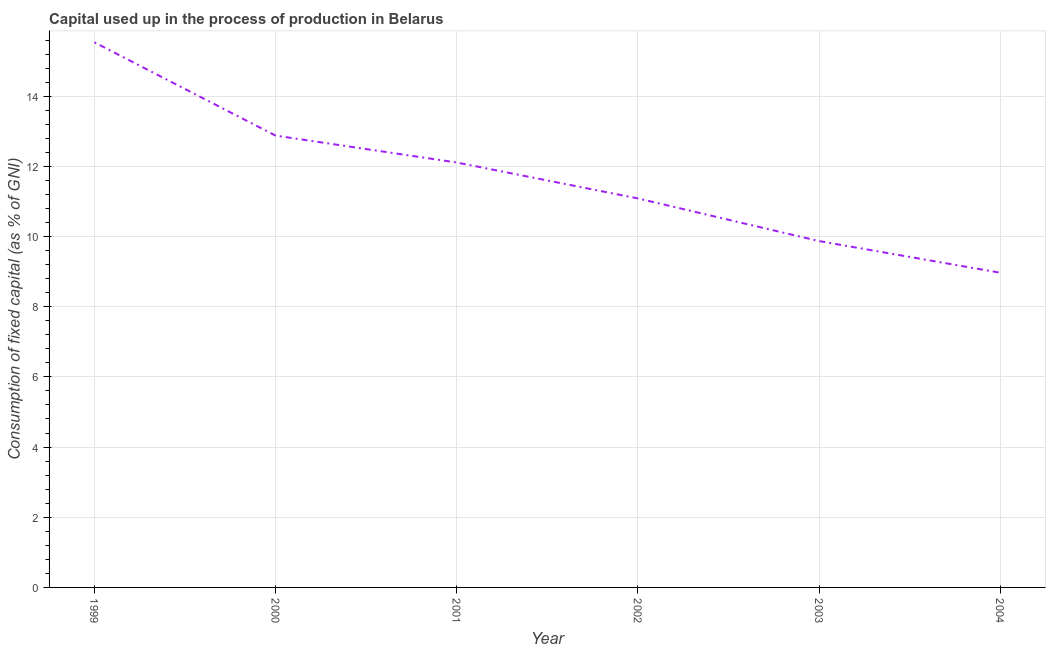What is the consumption of fixed capital in 2004?
Offer a terse response. 8.97. Across all years, what is the maximum consumption of fixed capital?
Offer a very short reply. 15.53. Across all years, what is the minimum consumption of fixed capital?
Your answer should be compact. 8.97. In which year was the consumption of fixed capital minimum?
Keep it short and to the point. 2004. What is the sum of the consumption of fixed capital?
Ensure brevity in your answer.  70.44. What is the difference between the consumption of fixed capital in 1999 and 2003?
Provide a short and direct response. 5.66. What is the average consumption of fixed capital per year?
Make the answer very short. 11.74. What is the median consumption of fixed capital?
Offer a very short reply. 11.6. In how many years, is the consumption of fixed capital greater than 8.4 %?
Provide a short and direct response. 6. Do a majority of the years between 2003 and 2002 (inclusive) have consumption of fixed capital greater than 13.2 %?
Keep it short and to the point. No. What is the ratio of the consumption of fixed capital in 1999 to that in 2004?
Your answer should be compact. 1.73. Is the difference between the consumption of fixed capital in 2000 and 2003 greater than the difference between any two years?
Make the answer very short. No. What is the difference between the highest and the second highest consumption of fixed capital?
Keep it short and to the point. 2.66. Is the sum of the consumption of fixed capital in 2000 and 2003 greater than the maximum consumption of fixed capital across all years?
Give a very brief answer. Yes. What is the difference between the highest and the lowest consumption of fixed capital?
Your answer should be very brief. 6.57. How many lines are there?
Offer a terse response. 1. What is the difference between two consecutive major ticks on the Y-axis?
Your answer should be very brief. 2. Are the values on the major ticks of Y-axis written in scientific E-notation?
Make the answer very short. No. Does the graph contain grids?
Your answer should be very brief. Yes. What is the title of the graph?
Offer a terse response. Capital used up in the process of production in Belarus. What is the label or title of the X-axis?
Ensure brevity in your answer.  Year. What is the label or title of the Y-axis?
Make the answer very short. Consumption of fixed capital (as % of GNI). What is the Consumption of fixed capital (as % of GNI) of 1999?
Your answer should be very brief. 15.53. What is the Consumption of fixed capital (as % of GNI) of 2000?
Your answer should be compact. 12.88. What is the Consumption of fixed capital (as % of GNI) of 2001?
Ensure brevity in your answer.  12.11. What is the Consumption of fixed capital (as % of GNI) of 2002?
Ensure brevity in your answer.  11.09. What is the Consumption of fixed capital (as % of GNI) in 2003?
Offer a terse response. 9.87. What is the Consumption of fixed capital (as % of GNI) in 2004?
Offer a very short reply. 8.97. What is the difference between the Consumption of fixed capital (as % of GNI) in 1999 and 2000?
Provide a short and direct response. 2.66. What is the difference between the Consumption of fixed capital (as % of GNI) in 1999 and 2001?
Provide a short and direct response. 3.42. What is the difference between the Consumption of fixed capital (as % of GNI) in 1999 and 2002?
Your response must be concise. 4.45. What is the difference between the Consumption of fixed capital (as % of GNI) in 1999 and 2003?
Your answer should be compact. 5.66. What is the difference between the Consumption of fixed capital (as % of GNI) in 1999 and 2004?
Offer a very short reply. 6.57. What is the difference between the Consumption of fixed capital (as % of GNI) in 2000 and 2001?
Your answer should be very brief. 0.77. What is the difference between the Consumption of fixed capital (as % of GNI) in 2000 and 2002?
Give a very brief answer. 1.79. What is the difference between the Consumption of fixed capital (as % of GNI) in 2000 and 2003?
Keep it short and to the point. 3.01. What is the difference between the Consumption of fixed capital (as % of GNI) in 2000 and 2004?
Your answer should be very brief. 3.91. What is the difference between the Consumption of fixed capital (as % of GNI) in 2001 and 2002?
Ensure brevity in your answer.  1.02. What is the difference between the Consumption of fixed capital (as % of GNI) in 2001 and 2003?
Your response must be concise. 2.24. What is the difference between the Consumption of fixed capital (as % of GNI) in 2001 and 2004?
Give a very brief answer. 3.14. What is the difference between the Consumption of fixed capital (as % of GNI) in 2002 and 2003?
Keep it short and to the point. 1.22. What is the difference between the Consumption of fixed capital (as % of GNI) in 2002 and 2004?
Provide a short and direct response. 2.12. What is the difference between the Consumption of fixed capital (as % of GNI) in 2003 and 2004?
Keep it short and to the point. 0.9. What is the ratio of the Consumption of fixed capital (as % of GNI) in 1999 to that in 2000?
Your answer should be compact. 1.21. What is the ratio of the Consumption of fixed capital (as % of GNI) in 1999 to that in 2001?
Your answer should be very brief. 1.28. What is the ratio of the Consumption of fixed capital (as % of GNI) in 1999 to that in 2002?
Offer a very short reply. 1.4. What is the ratio of the Consumption of fixed capital (as % of GNI) in 1999 to that in 2003?
Your answer should be compact. 1.57. What is the ratio of the Consumption of fixed capital (as % of GNI) in 1999 to that in 2004?
Keep it short and to the point. 1.73. What is the ratio of the Consumption of fixed capital (as % of GNI) in 2000 to that in 2001?
Provide a succinct answer. 1.06. What is the ratio of the Consumption of fixed capital (as % of GNI) in 2000 to that in 2002?
Offer a very short reply. 1.16. What is the ratio of the Consumption of fixed capital (as % of GNI) in 2000 to that in 2003?
Provide a short and direct response. 1.3. What is the ratio of the Consumption of fixed capital (as % of GNI) in 2000 to that in 2004?
Offer a terse response. 1.44. What is the ratio of the Consumption of fixed capital (as % of GNI) in 2001 to that in 2002?
Provide a succinct answer. 1.09. What is the ratio of the Consumption of fixed capital (as % of GNI) in 2001 to that in 2003?
Offer a very short reply. 1.23. What is the ratio of the Consumption of fixed capital (as % of GNI) in 2001 to that in 2004?
Ensure brevity in your answer.  1.35. What is the ratio of the Consumption of fixed capital (as % of GNI) in 2002 to that in 2003?
Keep it short and to the point. 1.12. What is the ratio of the Consumption of fixed capital (as % of GNI) in 2002 to that in 2004?
Offer a terse response. 1.24. What is the ratio of the Consumption of fixed capital (as % of GNI) in 2003 to that in 2004?
Offer a terse response. 1.1. 